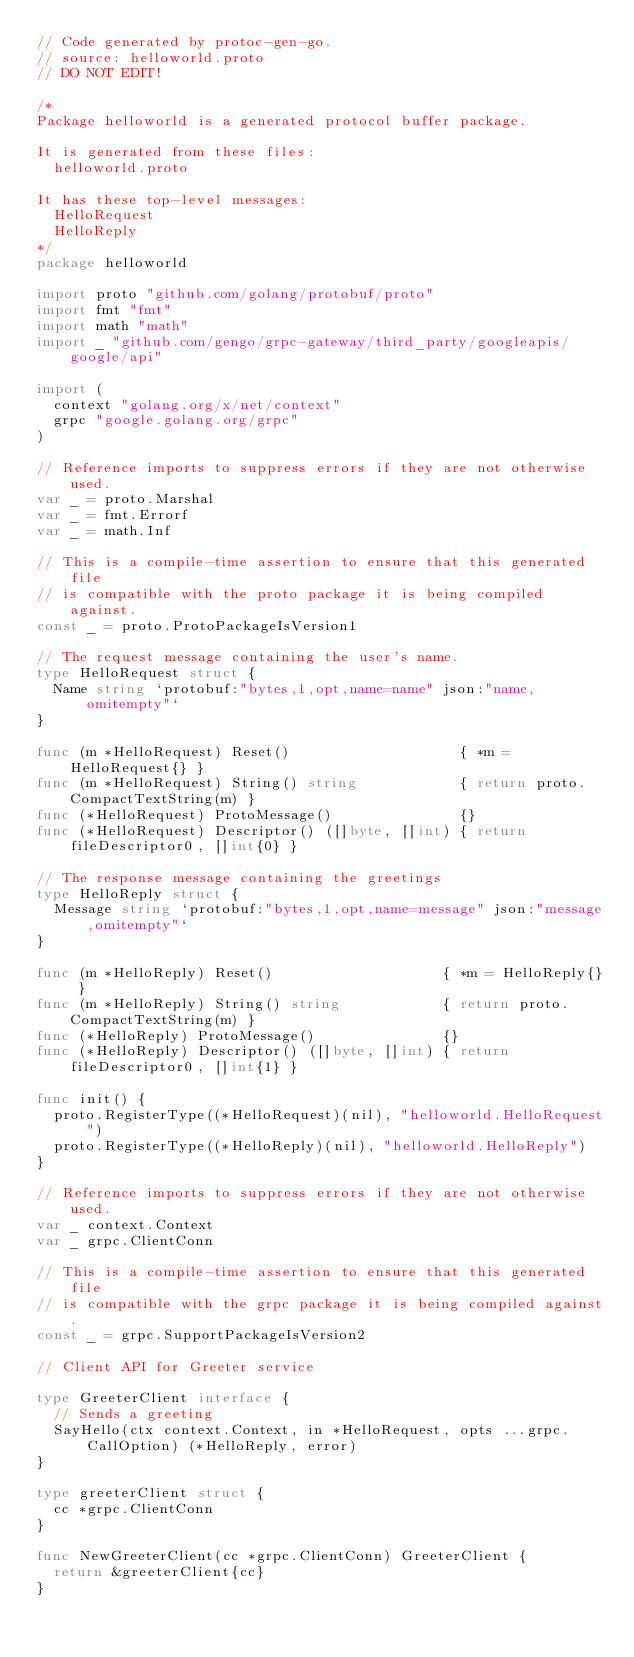<code> <loc_0><loc_0><loc_500><loc_500><_Go_>// Code generated by protoc-gen-go.
// source: helloworld.proto
// DO NOT EDIT!

/*
Package helloworld is a generated protocol buffer package.

It is generated from these files:
	helloworld.proto

It has these top-level messages:
	HelloRequest
	HelloReply
*/
package helloworld

import proto "github.com/golang/protobuf/proto"
import fmt "fmt"
import math "math"
import _ "github.com/gengo/grpc-gateway/third_party/googleapis/google/api"

import (
	context "golang.org/x/net/context"
	grpc "google.golang.org/grpc"
)

// Reference imports to suppress errors if they are not otherwise used.
var _ = proto.Marshal
var _ = fmt.Errorf
var _ = math.Inf

// This is a compile-time assertion to ensure that this generated file
// is compatible with the proto package it is being compiled against.
const _ = proto.ProtoPackageIsVersion1

// The request message containing the user's name.
type HelloRequest struct {
	Name string `protobuf:"bytes,1,opt,name=name" json:"name,omitempty"`
}

func (m *HelloRequest) Reset()                    { *m = HelloRequest{} }
func (m *HelloRequest) String() string            { return proto.CompactTextString(m) }
func (*HelloRequest) ProtoMessage()               {}
func (*HelloRequest) Descriptor() ([]byte, []int) { return fileDescriptor0, []int{0} }

// The response message containing the greetings
type HelloReply struct {
	Message string `protobuf:"bytes,1,opt,name=message" json:"message,omitempty"`
}

func (m *HelloReply) Reset()                    { *m = HelloReply{} }
func (m *HelloReply) String() string            { return proto.CompactTextString(m) }
func (*HelloReply) ProtoMessage()               {}
func (*HelloReply) Descriptor() ([]byte, []int) { return fileDescriptor0, []int{1} }

func init() {
	proto.RegisterType((*HelloRequest)(nil), "helloworld.HelloRequest")
	proto.RegisterType((*HelloReply)(nil), "helloworld.HelloReply")
}

// Reference imports to suppress errors if they are not otherwise used.
var _ context.Context
var _ grpc.ClientConn

// This is a compile-time assertion to ensure that this generated file
// is compatible with the grpc package it is being compiled against.
const _ = grpc.SupportPackageIsVersion2

// Client API for Greeter service

type GreeterClient interface {
	// Sends a greeting
	SayHello(ctx context.Context, in *HelloRequest, opts ...grpc.CallOption) (*HelloReply, error)
}

type greeterClient struct {
	cc *grpc.ClientConn
}

func NewGreeterClient(cc *grpc.ClientConn) GreeterClient {
	return &greeterClient{cc}
}
</code> 